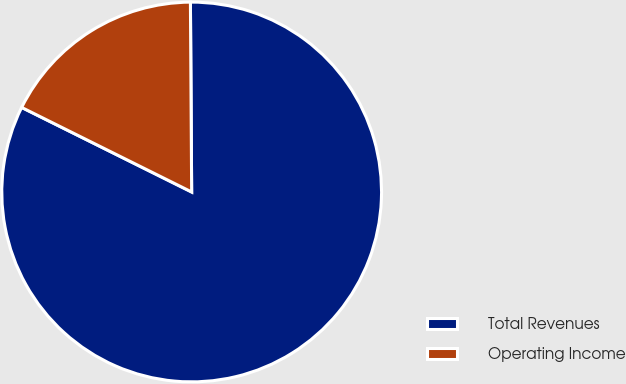Convert chart. <chart><loc_0><loc_0><loc_500><loc_500><pie_chart><fcel>Total Revenues<fcel>Operating Income<nl><fcel>82.45%<fcel>17.55%<nl></chart> 